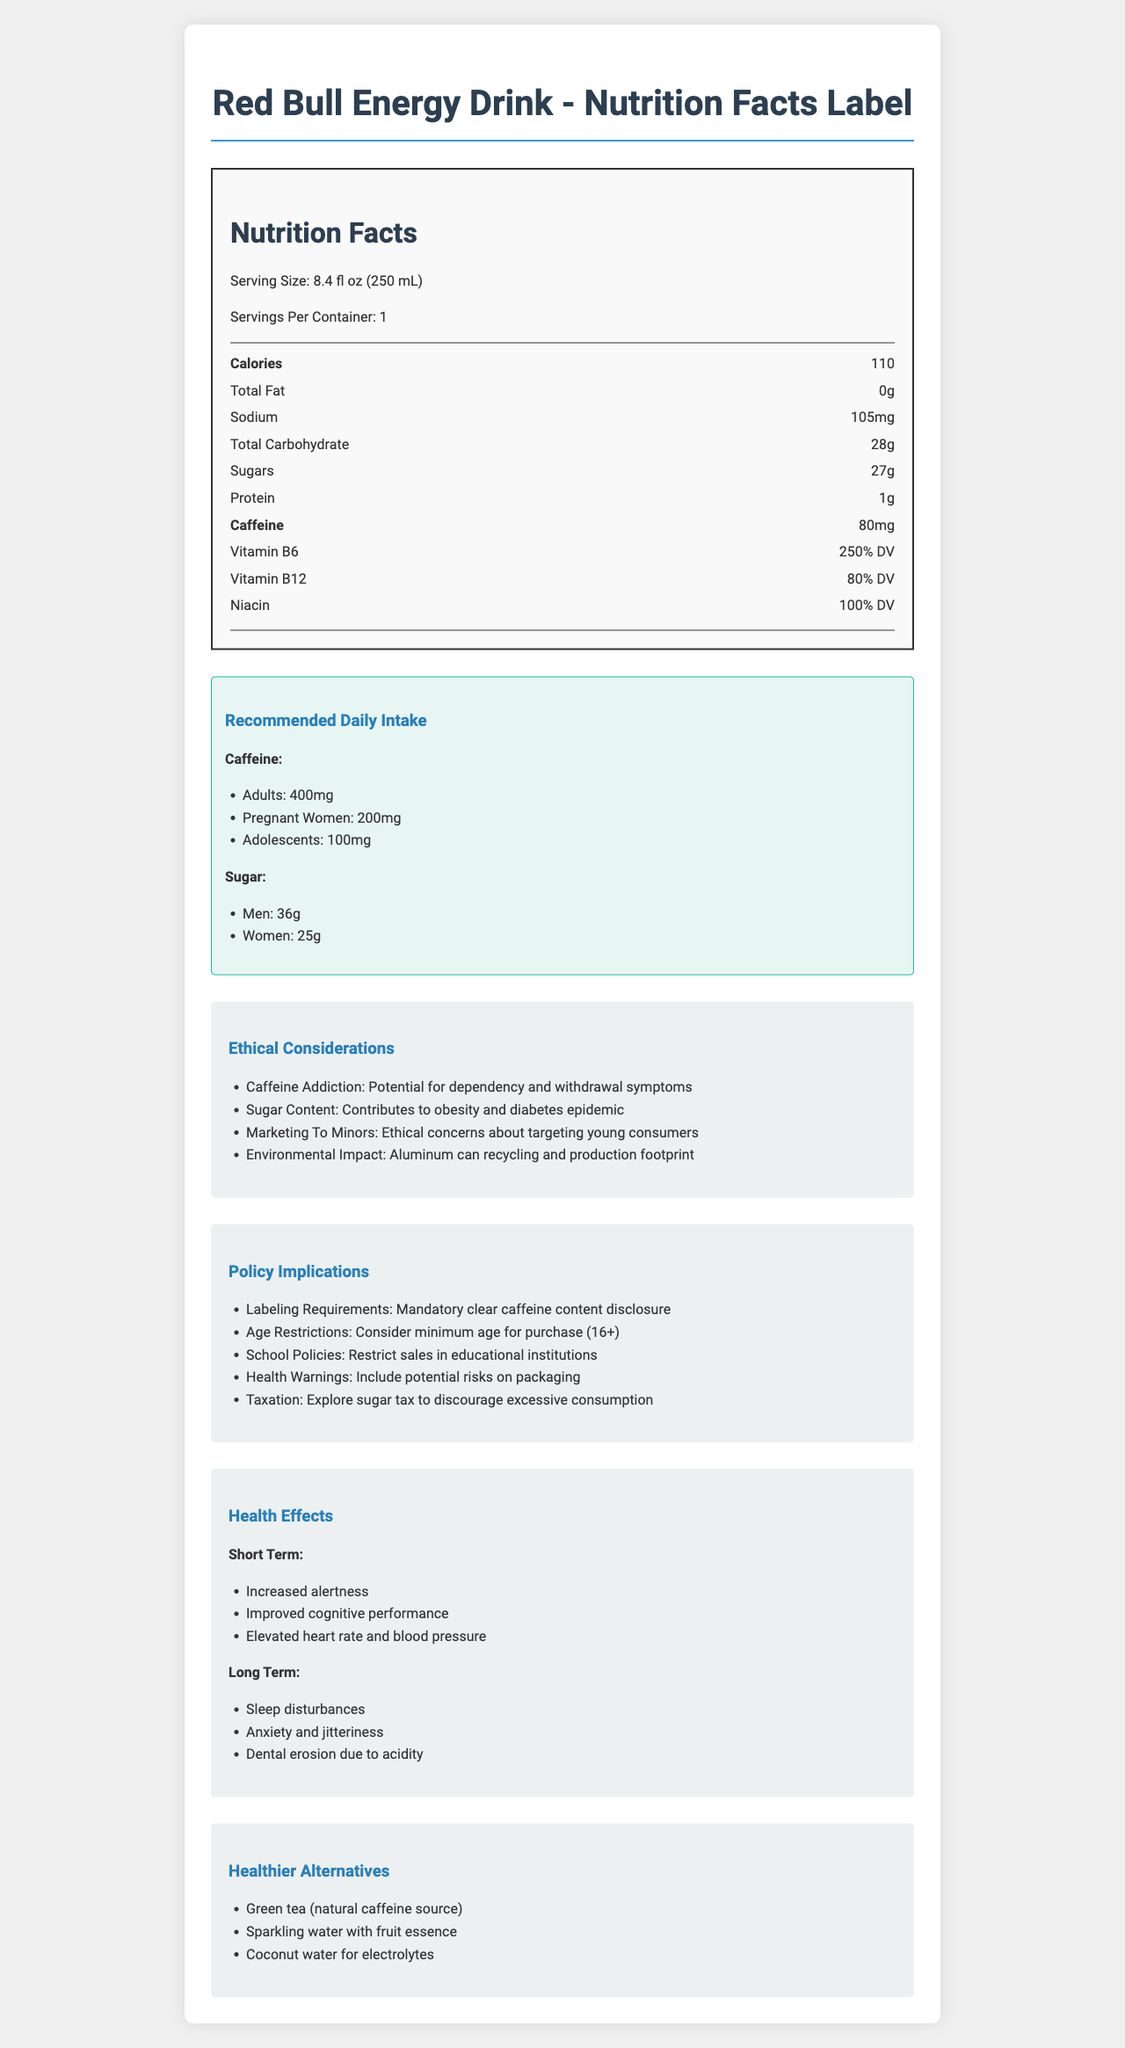what is the serving size of Red Bull Energy Drink? The serving size is clearly mentioned at the top of the document under the "Nutrition Facts" section.
Answer: 8.4 fl oz (250 mL) How much caffeine is in one serving of Red Bull Energy Drink? The caffeine content is directly listed under the "Nutrition Facts" section.
Answer: 80mg What is the recommended daily caffeine intake for pregnant women? The recommended daily intake for pregnant women is mentioned in the "Recommended Daily Intake" section.
Answer: 200mg How does the sugar content in one serving of Red Bull Energy Drink compare to the recommended daily intake for women? Red Bull contains 27g of sugar per serving, which exceeds the recommended daily intake for women (25g) by 2g.
Answer: Exceeds by 2g What percentage of the daily value for vitamin B6 does Red Bull provide? The percentage of the daily value for vitamin B6 provided by Red Bull is mentioned in the "Nutrition Facts" section.
Answer: 250% What are the ethical concerns regarding the marketing of energy drinks to minors? This information is found under the "Ethical Considerations" section.
Answer: Ethical concerns about targeting young consumers What long-term health effects are associated with the consumption of Red Bull? These long-term health effects are listed under the "Health Effects" section.
Answer: Sleep disturbances, Anxiety and jitteriness, Dental erosion due to acidity Which of the following is not a healthier alternative to Red Bull Energy Drink? I. Green tea II. Sparkling water with fruit essence III. Soda IV. Coconut water Soda is not listed among the healthier alternatives in the "Alternatives" section.
Answer: III. Soda Does Red Bull contain any protein? The document lists 1g of protein in the "Nutrition Facts" section.
Answer: Yes Explain the main ethical considerations surrounding the consumption of Red Bull Energy Drink. These points are detailed under the "Ethical Considerations" section, outlining various concerns related to the product's consumption and its broader impact.
Answer: The main ethical considerations include the potential for caffeine addiction, the high sugar content contributing to obesity and diabetes, the ethical concerns about marketing to minors, and the environmental impact of aluminum can production and recycling. How much sodium does one serving of Red Bull Energy Drink contain? The sodium content is specified in the "Nutrition Facts" section.
Answer: 105mg What are some short-term benefits of consuming Red Bull Energy Drink? These benefits are listed in the "Short Term" part of the "Health Effects" section.
Answer: Increased alertness, Improved cognitive performance, Elevated heart rate and blood pressure Can Red Bull be safely consumed by adolescents in high quantities? The document recommends a daily caffeine intake for adolescents of 100mg, which is significantly less than the content in one serving of Red Bull, raising concerns about high consumption.
Answer: No Is the document able to provide information about the refund policy for Red Bull Energy Drink? The document does not contain any information related to refund policies.
Answer: Cannot be determined Summarize the main idea of the document. The document's primary aim is to inform readers about the nutritional content, health impact, and broader ethical and policy issues associated with Red Bull Energy Drink.
Answer: The document provides comprehensive details about the nutrition facts of Red Bull Energy Drink, including its serving size, calories, and nutrient content. It outlines the recommended daily intake of caffeine and sugar, ethical considerations related to its consumption, policy implications, health effects, and potential healthier alternatives. 